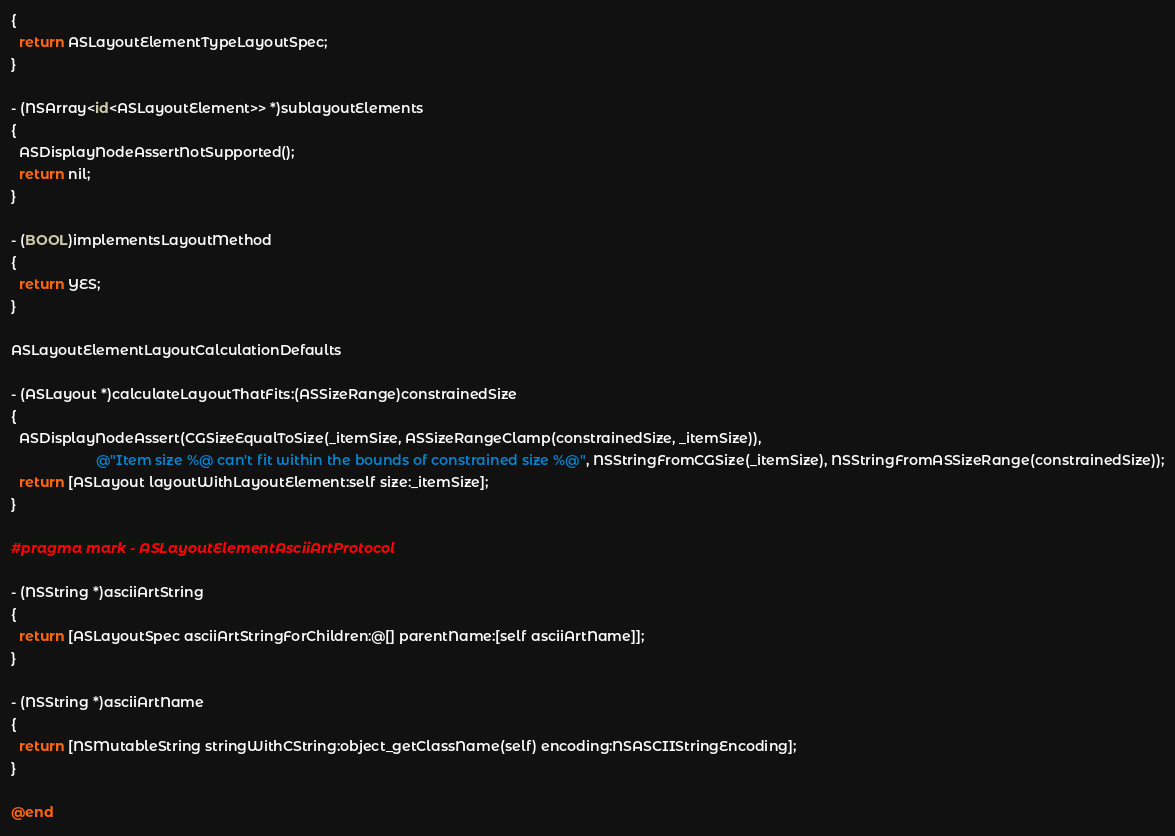Convert code to text. <code><loc_0><loc_0><loc_500><loc_500><_ObjectiveC_>{
  return ASLayoutElementTypeLayoutSpec;
}

- (NSArray<id<ASLayoutElement>> *)sublayoutElements
{
  ASDisplayNodeAssertNotSupported();
  return nil;
}

- (BOOL)implementsLayoutMethod
{
  return YES;
}

ASLayoutElementLayoutCalculationDefaults

- (ASLayout *)calculateLayoutThatFits:(ASSizeRange)constrainedSize
{
  ASDisplayNodeAssert(CGSizeEqualToSize(_itemSize, ASSizeRangeClamp(constrainedSize, _itemSize)),
                      @"Item size %@ can't fit within the bounds of constrained size %@", NSStringFromCGSize(_itemSize), NSStringFromASSizeRange(constrainedSize));
  return [ASLayout layoutWithLayoutElement:self size:_itemSize];
}

#pragma mark - ASLayoutElementAsciiArtProtocol

- (NSString *)asciiArtString
{
  return [ASLayoutSpec asciiArtStringForChildren:@[] parentName:[self asciiArtName]];
}

- (NSString *)asciiArtName
{
  return [NSMutableString stringWithCString:object_getClassName(self) encoding:NSASCIIStringEncoding];
}

@end
</code> 